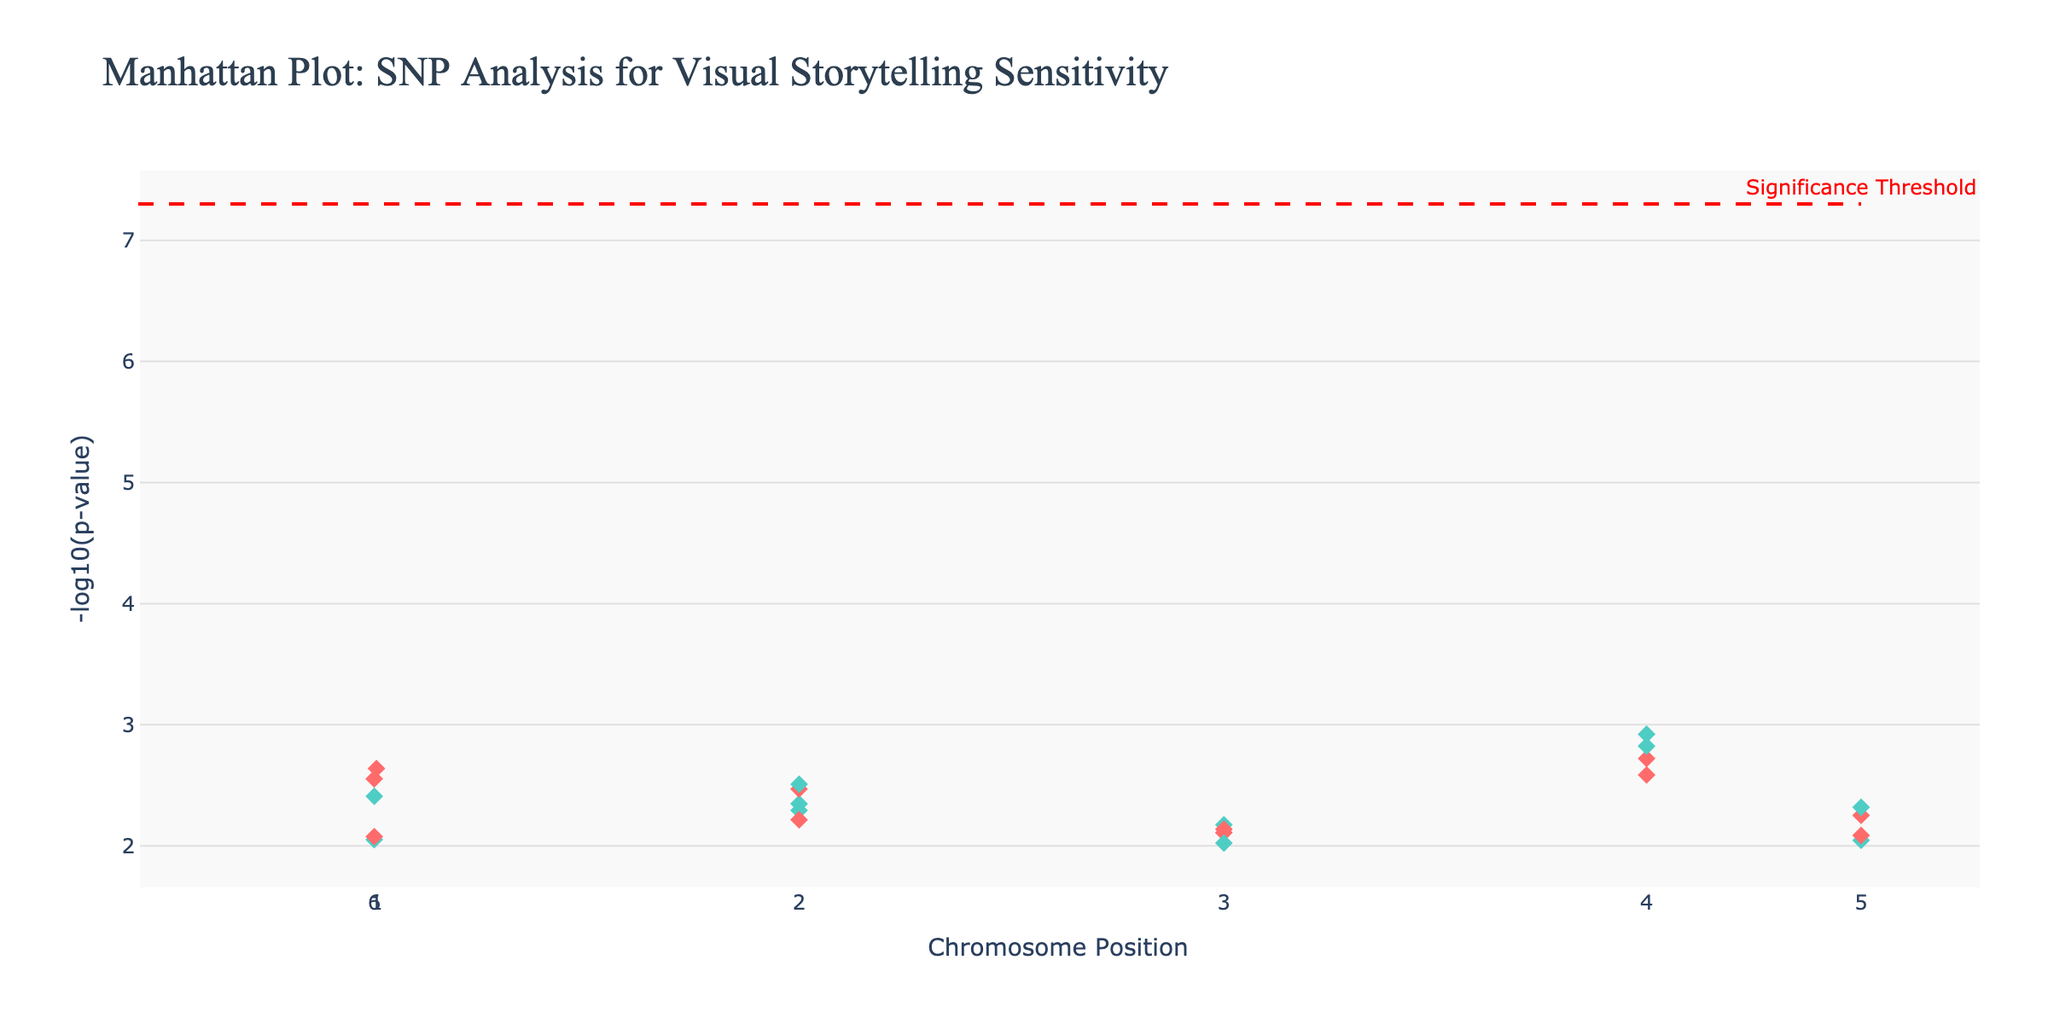what is the title of the plot? The title of the plot appears at the top and is usually designed to convey the main message or subject of the visualization. To find the title, look at the top of the plot. The title indicates what the plot is about.
Answer: Manhattan Plot: SNP Analysis for Visual Storytelling Sensitivity How many chromosomes are included in the plot? Each unique chromosome is represented separately in a Manhattan plot. To find the number, check the different groups of data points along the x-axis and count the chromosomes listed.
Answer: 22 Which SNP has the smallest p-value, and on which chromosome and position is it located? The smallest p-value corresponds to the highest point in terms of the -log10(p-value) on the y-axis. Locate the highest point, then refer to the hovertext or the corresponding SNP, chromosome, and position.
Answer: rs4680 on chromosome 4 at position 7890123 What is the general color scheme used in the plot, and how are the colors assigned? Manhattan plots often use alternating colors to distinguish between chromosomes. Check the colors of the data points to see the pattern. The alternating color scheme helps to visually separate the chromosomes.
Answer: Alternating red and teal How many SNPs have p-values below the significance threshold? The significance threshold is marked by a red dashed line. Count the number of data points above this threshold line. Each point above the line corresponds to an SNP with a p-value below the threshold.
Answer: 0 What is the significance threshold value represented by the dashed line? The significance threshold is visualized by a dashed line. To find its value, look at the annotation text or the y-axis intersection of the line.
Answer: 5e-8 Which chromosome has the most SNPs with p-values under 0.005? To determine this, identify the data points with y-values (i.e., -log10(p-value)) corresponding to p-values less than 0.005 across each chromosome. The chromosome with the most such points is the answer. Count how many such points each chromosome has.
Answer: Chromosome 4 On which chromosome and at what position is the SNP rs7412 located? Identify the hovertext or the specific data point corresponding to the SNP rs7412. This information will specify the chromosome number and the position on that chromosome.
Answer: Chromosome 7 at position 3456789 Rank the chromosomes based on the highest -log10(p-value) to lowest. To rank the chromosomes, compare the highest points on the y-axis for each chromosome. List the chromosomes in descending order based on their highest -log10(p-value).
Answer: 4, 14, 9, 19, 1, 11, 7, 22, 16, 2, 20, 12, 5, 8, 13, 17, 3, 18, 10, 15, 21, 6 